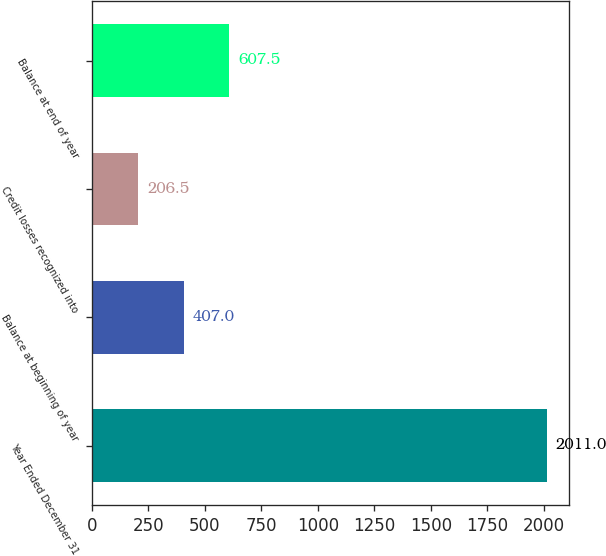Convert chart to OTSL. <chart><loc_0><loc_0><loc_500><loc_500><bar_chart><fcel>Year Ended December 31<fcel>Balance at beginning of year<fcel>Credit losses recognized into<fcel>Balance at end of year<nl><fcel>2011<fcel>407<fcel>206.5<fcel>607.5<nl></chart> 